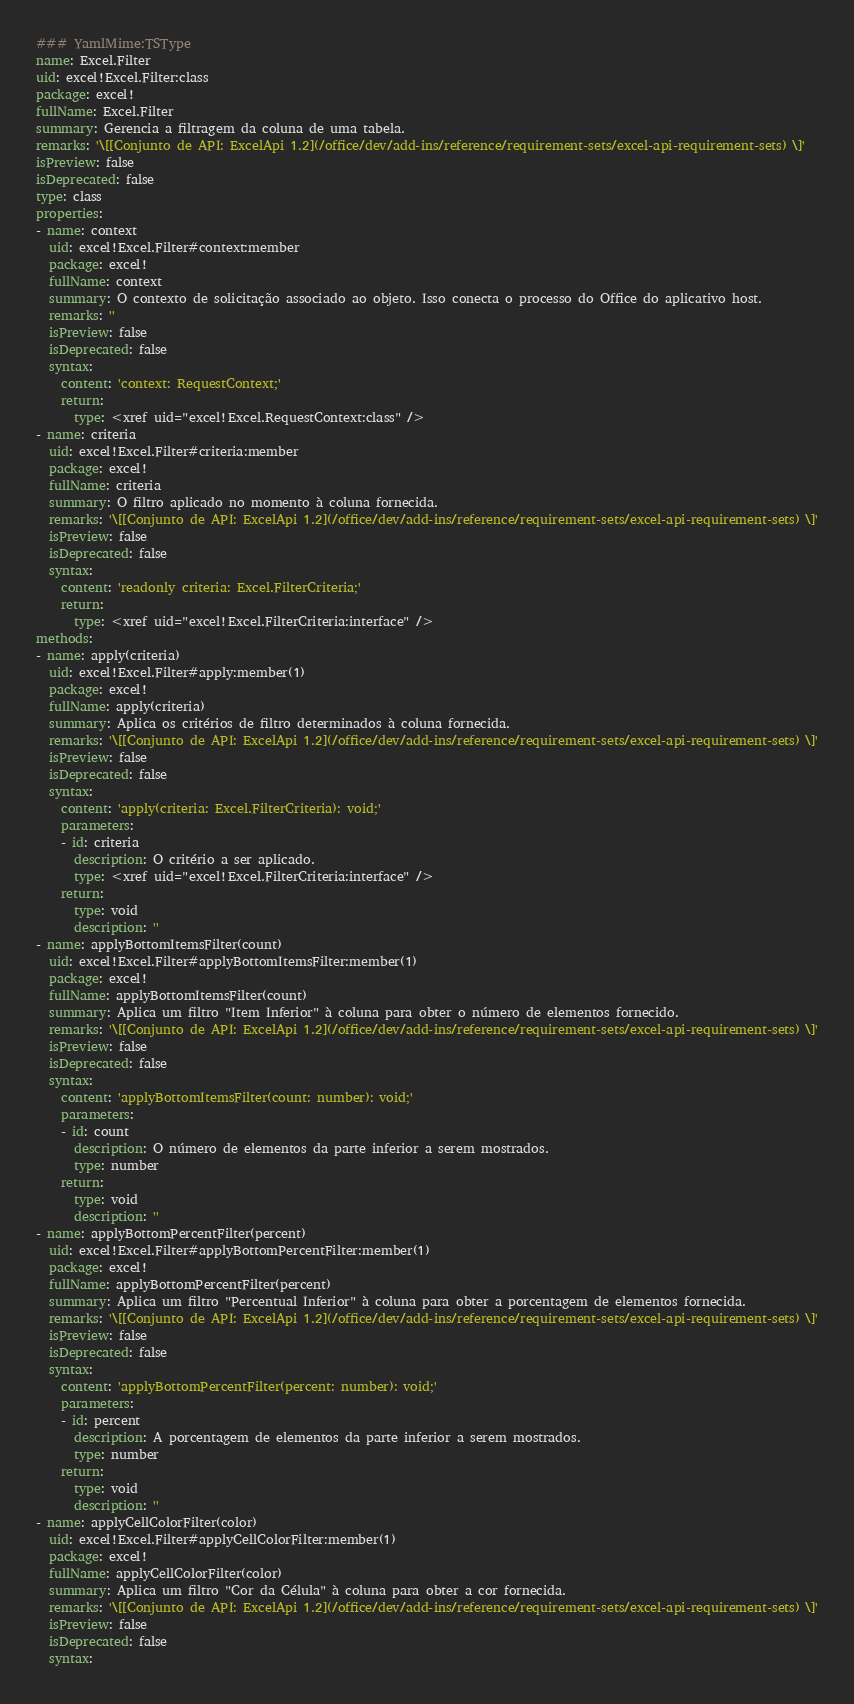Convert code to text. <code><loc_0><loc_0><loc_500><loc_500><_YAML_>### YamlMime:TSType
name: Excel.Filter
uid: excel!Excel.Filter:class
package: excel!
fullName: Excel.Filter
summary: Gerencia a filtragem da coluna de uma tabela.
remarks: '\[[Conjunto de API: ExcelApi 1.2](/office/dev/add-ins/reference/requirement-sets/excel-api-requirement-sets) \]'
isPreview: false
isDeprecated: false
type: class
properties:
- name: context
  uid: excel!Excel.Filter#context:member
  package: excel!
  fullName: context
  summary: O contexto de solicitação associado ao objeto. Isso conecta o processo do Office do aplicativo host.
  remarks: ''
  isPreview: false
  isDeprecated: false
  syntax:
    content: 'context: RequestContext;'
    return:
      type: <xref uid="excel!Excel.RequestContext:class" />
- name: criteria
  uid: excel!Excel.Filter#criteria:member
  package: excel!
  fullName: criteria
  summary: O filtro aplicado no momento à coluna fornecida.
  remarks: '\[[Conjunto de API: ExcelApi 1.2](/office/dev/add-ins/reference/requirement-sets/excel-api-requirement-sets) \]'
  isPreview: false
  isDeprecated: false
  syntax:
    content: 'readonly criteria: Excel.FilterCriteria;'
    return:
      type: <xref uid="excel!Excel.FilterCriteria:interface" />
methods:
- name: apply(criteria)
  uid: excel!Excel.Filter#apply:member(1)
  package: excel!
  fullName: apply(criteria)
  summary: Aplica os critérios de filtro determinados à coluna fornecida.
  remarks: '\[[Conjunto de API: ExcelApi 1.2](/office/dev/add-ins/reference/requirement-sets/excel-api-requirement-sets) \]'
  isPreview: false
  isDeprecated: false
  syntax:
    content: 'apply(criteria: Excel.FilterCriteria): void;'
    parameters:
    - id: criteria
      description: O critério a ser aplicado.
      type: <xref uid="excel!Excel.FilterCriteria:interface" />
    return:
      type: void
      description: ''
- name: applyBottomItemsFilter(count)
  uid: excel!Excel.Filter#applyBottomItemsFilter:member(1)
  package: excel!
  fullName: applyBottomItemsFilter(count)
  summary: Aplica um filtro "Item Inferior" à coluna para obter o número de elementos fornecido.
  remarks: '\[[Conjunto de API: ExcelApi 1.2](/office/dev/add-ins/reference/requirement-sets/excel-api-requirement-sets) \]'
  isPreview: false
  isDeprecated: false
  syntax:
    content: 'applyBottomItemsFilter(count: number): void;'
    parameters:
    - id: count
      description: O número de elementos da parte inferior a serem mostrados.
      type: number
    return:
      type: void
      description: ''
- name: applyBottomPercentFilter(percent)
  uid: excel!Excel.Filter#applyBottomPercentFilter:member(1)
  package: excel!
  fullName: applyBottomPercentFilter(percent)
  summary: Aplica um filtro "Percentual Inferior" à coluna para obter a porcentagem de elementos fornecida.
  remarks: '\[[Conjunto de API: ExcelApi 1.2](/office/dev/add-ins/reference/requirement-sets/excel-api-requirement-sets) \]'
  isPreview: false
  isDeprecated: false
  syntax:
    content: 'applyBottomPercentFilter(percent: number): void;'
    parameters:
    - id: percent
      description: A porcentagem de elementos da parte inferior a serem mostrados.
      type: number
    return:
      type: void
      description: ''
- name: applyCellColorFilter(color)
  uid: excel!Excel.Filter#applyCellColorFilter:member(1)
  package: excel!
  fullName: applyCellColorFilter(color)
  summary: Aplica um filtro "Cor da Célula" à coluna para obter a cor fornecida.
  remarks: '\[[Conjunto de API: ExcelApi 1.2](/office/dev/add-ins/reference/requirement-sets/excel-api-requirement-sets) \]'
  isPreview: false
  isDeprecated: false
  syntax:</code> 